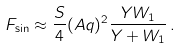<formula> <loc_0><loc_0><loc_500><loc_500>F _ { \sin } \approx \frac { S } { 4 } ( A q ) ^ { 2 } \frac { Y W _ { 1 } } { Y + W _ { 1 } } \, .</formula> 